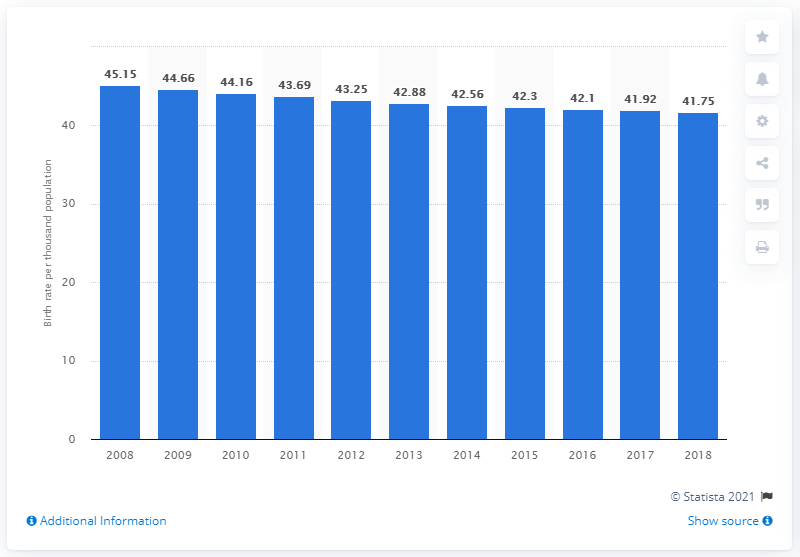List a handful of essential elements in this visual. The crude birth rate in Somalia in 2018 was 41.75. 